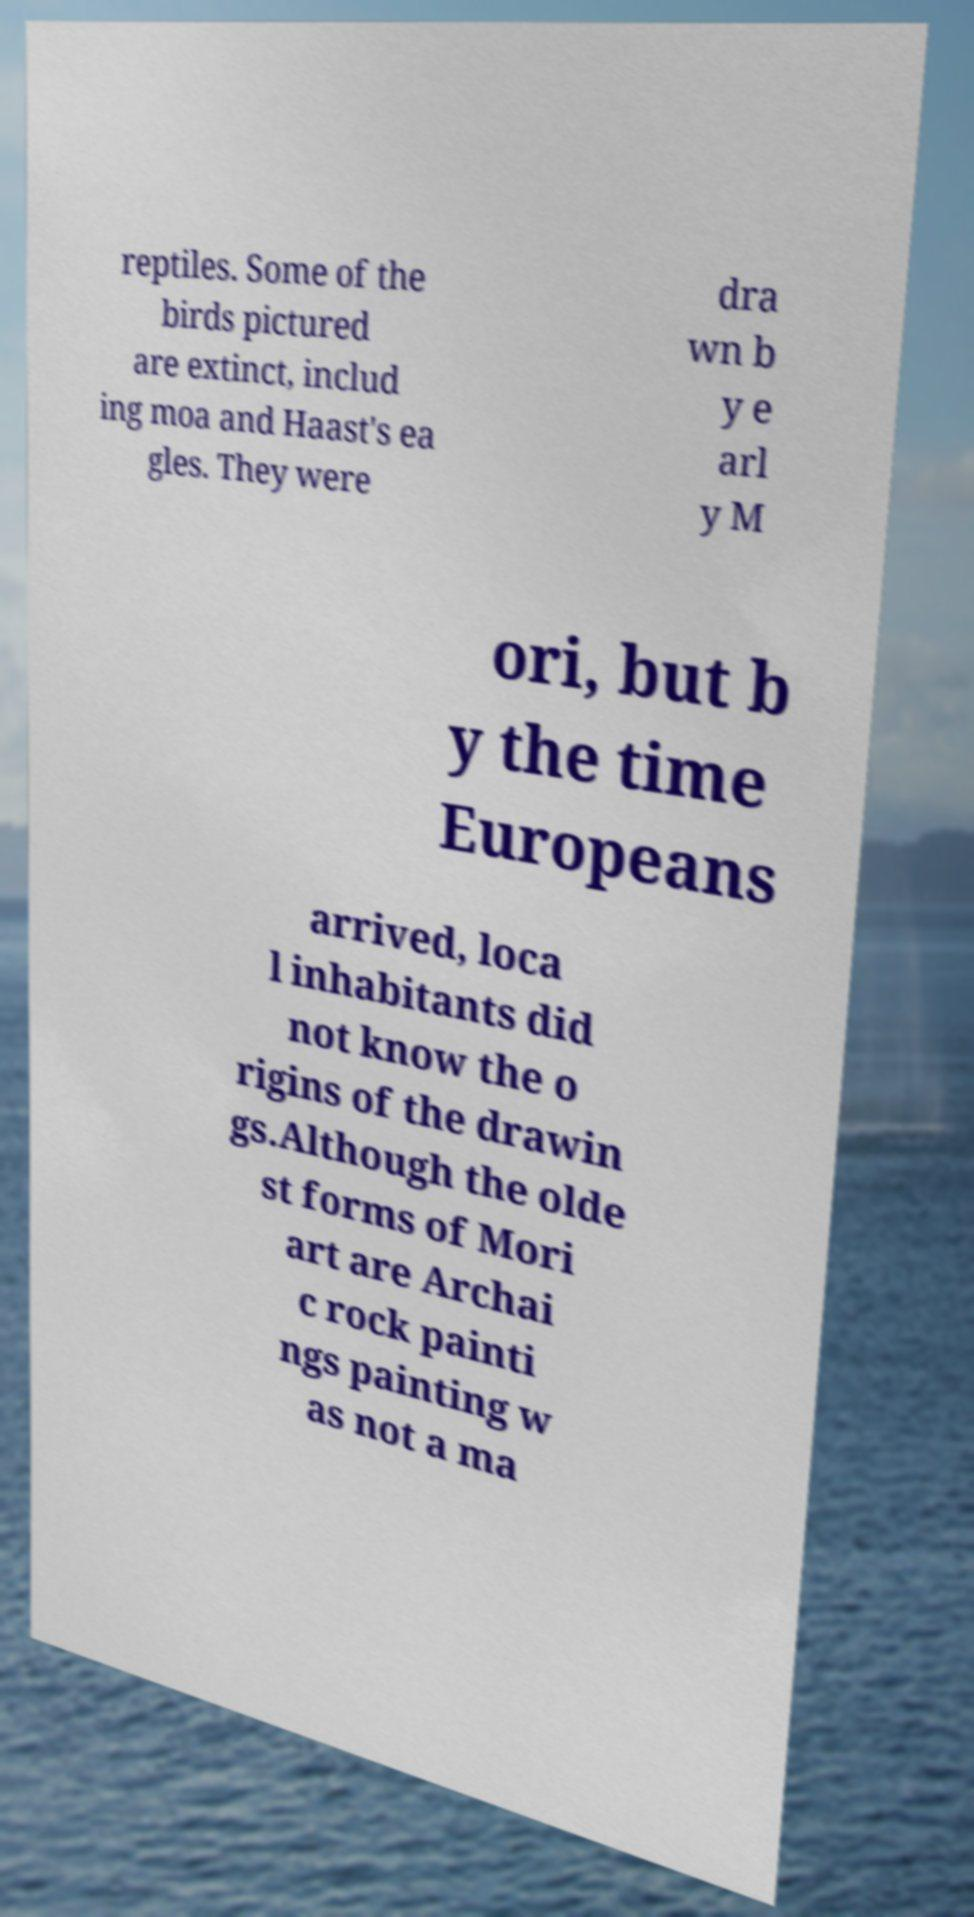Please read and relay the text visible in this image. What does it say? reptiles. Some of the birds pictured are extinct, includ ing moa and Haast's ea gles. They were dra wn b y e arl y M ori, but b y the time Europeans arrived, loca l inhabitants did not know the o rigins of the drawin gs.Although the olde st forms of Mori art are Archai c rock painti ngs painting w as not a ma 